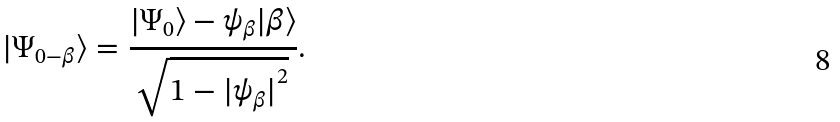Convert formula to latex. <formula><loc_0><loc_0><loc_500><loc_500>| \Psi _ { 0 - \beta } \rangle = \frac { | \Psi _ { 0 } \rangle - \psi _ { \beta } | \beta \rangle } { \sqrt { 1 - { | \psi _ { \beta } | } ^ { 2 } } } .</formula> 